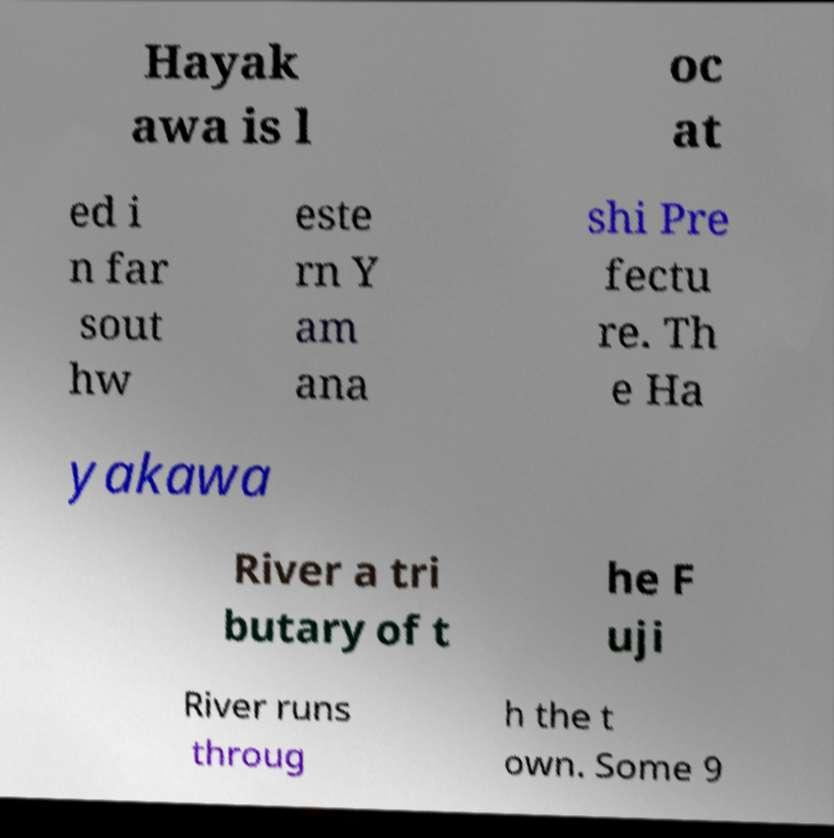Please read and relay the text visible in this image. What does it say? Hayak awa is l oc at ed i n far sout hw este rn Y am ana shi Pre fectu re. Th e Ha yakawa River a tri butary of t he F uji River runs throug h the t own. Some 9 